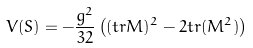Convert formula to latex. <formula><loc_0><loc_0><loc_500><loc_500>V ( S ) = - \frac { g ^ { 2 } } { 3 2 } \left ( ( t r M ) ^ { 2 } - 2 t r ( M ^ { 2 } ) \right )</formula> 